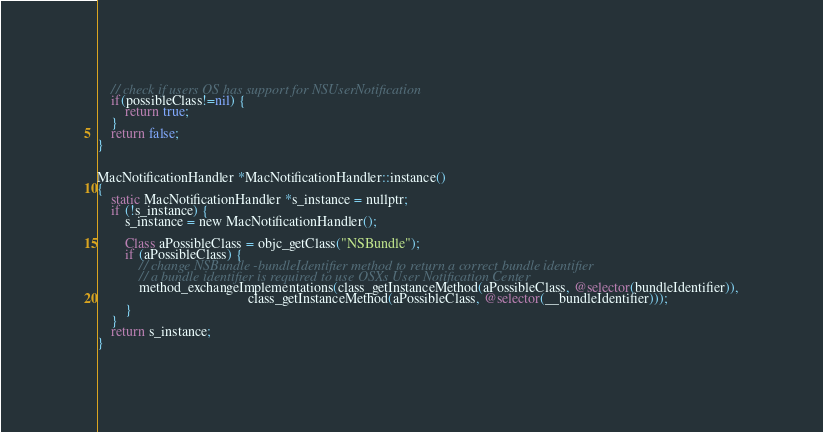Convert code to text. <code><loc_0><loc_0><loc_500><loc_500><_ObjectiveC_>    // check if users OS has support for NSUserNotification
    if(possibleClass!=nil) {
        return true;
    }
    return false;
}


MacNotificationHandler *MacNotificationHandler::instance()
{
    static MacNotificationHandler *s_instance = nullptr;
    if (!s_instance) {
        s_instance = new MacNotificationHandler();

        Class aPossibleClass = objc_getClass("NSBundle");
        if (aPossibleClass) {
            // change NSBundle -bundleIdentifier method to return a correct bundle identifier
            // a bundle identifier is required to use OSXs User Notification Center
            method_exchangeImplementations(class_getInstanceMethod(aPossibleClass, @selector(bundleIdentifier)),
                                           class_getInstanceMethod(aPossibleClass, @selector(__bundleIdentifier)));
        }
    }
    return s_instance;
}
</code> 